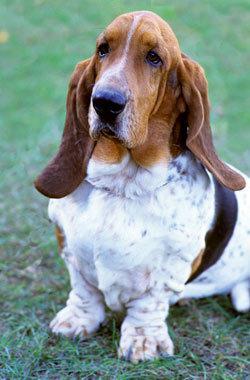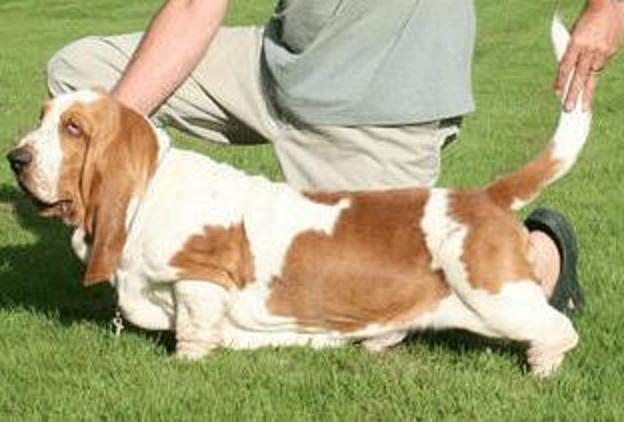The first image is the image on the left, the second image is the image on the right. For the images shown, is this caption "An image shows a brown and white basset on grass in profile facing left." true? Answer yes or no. Yes. 